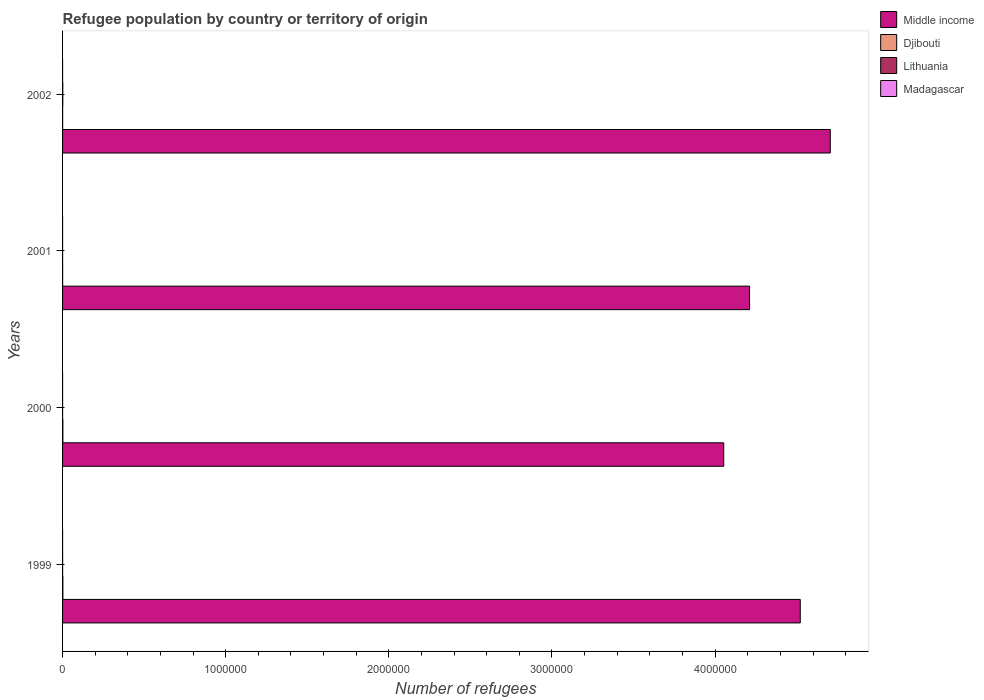How many groups of bars are there?
Ensure brevity in your answer.  4. Are the number of bars on each tick of the Y-axis equal?
Your answer should be very brief. Yes. What is the label of the 4th group of bars from the top?
Provide a short and direct response. 1999. In how many cases, is the number of bars for a given year not equal to the number of legend labels?
Provide a short and direct response. 0. What is the number of refugees in Lithuania in 1999?
Give a very brief answer. 258. Across all years, what is the maximum number of refugees in Djibouti?
Offer a very short reply. 1910. Across all years, what is the minimum number of refugees in Madagascar?
Your answer should be very brief. 40. In which year was the number of refugees in Madagascar minimum?
Your answer should be very brief. 2001. What is the difference between the number of refugees in Djibouti in 1999 and that in 2000?
Provide a succinct answer. -31. What is the difference between the number of refugees in Djibouti in 2001 and the number of refugees in Lithuania in 1999?
Ensure brevity in your answer.  194. What is the average number of refugees in Madagascar per year?
Your answer should be compact. 50.25. In the year 2001, what is the difference between the number of refugees in Middle income and number of refugees in Madagascar?
Provide a succinct answer. 4.21e+06. What is the ratio of the number of refugees in Djibouti in 2000 to that in 2002?
Your response must be concise. 4.06. Is the number of refugees in Madagascar in 2000 less than that in 2002?
Your answer should be very brief. No. Is the difference between the number of refugees in Middle income in 2000 and 2002 greater than the difference between the number of refugees in Madagascar in 2000 and 2002?
Your answer should be very brief. No. What is the difference between the highest and the lowest number of refugees in Djibouti?
Offer a terse response. 1458. Is the sum of the number of refugees in Lithuania in 2000 and 2001 greater than the maximum number of refugees in Madagascar across all years?
Provide a short and direct response. Yes. Is it the case that in every year, the sum of the number of refugees in Middle income and number of refugees in Madagascar is greater than the sum of number of refugees in Lithuania and number of refugees in Djibouti?
Provide a short and direct response. Yes. What does the 3rd bar from the top in 2001 represents?
Ensure brevity in your answer.  Djibouti. What does the 2nd bar from the bottom in 2001 represents?
Ensure brevity in your answer.  Djibouti. How many bars are there?
Offer a terse response. 16. How many years are there in the graph?
Your answer should be compact. 4. What is the difference between two consecutive major ticks on the X-axis?
Provide a short and direct response. 1.00e+06. Are the values on the major ticks of X-axis written in scientific E-notation?
Make the answer very short. No. Does the graph contain any zero values?
Your answer should be compact. No. Where does the legend appear in the graph?
Keep it short and to the point. Top right. What is the title of the graph?
Provide a short and direct response. Refugee population by country or territory of origin. Does "East Asia (developing only)" appear as one of the legend labels in the graph?
Your answer should be compact. No. What is the label or title of the X-axis?
Make the answer very short. Number of refugees. What is the label or title of the Y-axis?
Ensure brevity in your answer.  Years. What is the Number of refugees of Middle income in 1999?
Your answer should be very brief. 4.52e+06. What is the Number of refugees of Djibouti in 1999?
Keep it short and to the point. 1879. What is the Number of refugees of Lithuania in 1999?
Offer a very short reply. 258. What is the Number of refugees of Madagascar in 1999?
Offer a terse response. 54. What is the Number of refugees of Middle income in 2000?
Offer a terse response. 4.05e+06. What is the Number of refugees in Djibouti in 2000?
Offer a very short reply. 1910. What is the Number of refugees in Lithuania in 2000?
Give a very brief answer. 163. What is the Number of refugees in Madagascar in 2000?
Offer a very short reply. 54. What is the Number of refugees in Middle income in 2001?
Keep it short and to the point. 4.21e+06. What is the Number of refugees of Djibouti in 2001?
Offer a very short reply. 452. What is the Number of refugees of Lithuania in 2001?
Provide a short and direct response. 216. What is the Number of refugees in Madagascar in 2001?
Make the answer very short. 40. What is the Number of refugees in Middle income in 2002?
Make the answer very short. 4.71e+06. What is the Number of refugees of Djibouti in 2002?
Ensure brevity in your answer.  471. What is the Number of refugees of Lithuania in 2002?
Offer a terse response. 1371. Across all years, what is the maximum Number of refugees of Middle income?
Your response must be concise. 4.71e+06. Across all years, what is the maximum Number of refugees in Djibouti?
Make the answer very short. 1910. Across all years, what is the maximum Number of refugees of Lithuania?
Provide a succinct answer. 1371. Across all years, what is the minimum Number of refugees in Middle income?
Provide a succinct answer. 4.05e+06. Across all years, what is the minimum Number of refugees of Djibouti?
Provide a succinct answer. 452. Across all years, what is the minimum Number of refugees in Lithuania?
Provide a short and direct response. 163. Across all years, what is the minimum Number of refugees in Madagascar?
Make the answer very short. 40. What is the total Number of refugees in Middle income in the graph?
Keep it short and to the point. 1.75e+07. What is the total Number of refugees of Djibouti in the graph?
Give a very brief answer. 4712. What is the total Number of refugees of Lithuania in the graph?
Offer a very short reply. 2008. What is the total Number of refugees of Madagascar in the graph?
Give a very brief answer. 201. What is the difference between the Number of refugees of Middle income in 1999 and that in 2000?
Offer a terse response. 4.69e+05. What is the difference between the Number of refugees in Djibouti in 1999 and that in 2000?
Provide a succinct answer. -31. What is the difference between the Number of refugees of Middle income in 1999 and that in 2001?
Ensure brevity in your answer.  3.11e+05. What is the difference between the Number of refugees in Djibouti in 1999 and that in 2001?
Ensure brevity in your answer.  1427. What is the difference between the Number of refugees in Lithuania in 1999 and that in 2001?
Make the answer very short. 42. What is the difference between the Number of refugees in Madagascar in 1999 and that in 2001?
Provide a short and direct response. 14. What is the difference between the Number of refugees in Middle income in 1999 and that in 2002?
Offer a terse response. -1.84e+05. What is the difference between the Number of refugees of Djibouti in 1999 and that in 2002?
Keep it short and to the point. 1408. What is the difference between the Number of refugees of Lithuania in 1999 and that in 2002?
Offer a very short reply. -1113. What is the difference between the Number of refugees in Middle income in 2000 and that in 2001?
Keep it short and to the point. -1.58e+05. What is the difference between the Number of refugees of Djibouti in 2000 and that in 2001?
Your response must be concise. 1458. What is the difference between the Number of refugees of Lithuania in 2000 and that in 2001?
Your answer should be very brief. -53. What is the difference between the Number of refugees in Middle income in 2000 and that in 2002?
Make the answer very short. -6.53e+05. What is the difference between the Number of refugees in Djibouti in 2000 and that in 2002?
Your answer should be compact. 1439. What is the difference between the Number of refugees in Lithuania in 2000 and that in 2002?
Offer a terse response. -1208. What is the difference between the Number of refugees of Madagascar in 2000 and that in 2002?
Your answer should be compact. 1. What is the difference between the Number of refugees of Middle income in 2001 and that in 2002?
Offer a terse response. -4.95e+05. What is the difference between the Number of refugees in Lithuania in 2001 and that in 2002?
Keep it short and to the point. -1155. What is the difference between the Number of refugees of Madagascar in 2001 and that in 2002?
Provide a short and direct response. -13. What is the difference between the Number of refugees in Middle income in 1999 and the Number of refugees in Djibouti in 2000?
Provide a short and direct response. 4.52e+06. What is the difference between the Number of refugees in Middle income in 1999 and the Number of refugees in Lithuania in 2000?
Make the answer very short. 4.52e+06. What is the difference between the Number of refugees in Middle income in 1999 and the Number of refugees in Madagascar in 2000?
Give a very brief answer. 4.52e+06. What is the difference between the Number of refugees in Djibouti in 1999 and the Number of refugees in Lithuania in 2000?
Your answer should be compact. 1716. What is the difference between the Number of refugees in Djibouti in 1999 and the Number of refugees in Madagascar in 2000?
Give a very brief answer. 1825. What is the difference between the Number of refugees of Lithuania in 1999 and the Number of refugees of Madagascar in 2000?
Keep it short and to the point. 204. What is the difference between the Number of refugees in Middle income in 1999 and the Number of refugees in Djibouti in 2001?
Give a very brief answer. 4.52e+06. What is the difference between the Number of refugees in Middle income in 1999 and the Number of refugees in Lithuania in 2001?
Offer a terse response. 4.52e+06. What is the difference between the Number of refugees in Middle income in 1999 and the Number of refugees in Madagascar in 2001?
Your response must be concise. 4.52e+06. What is the difference between the Number of refugees in Djibouti in 1999 and the Number of refugees in Lithuania in 2001?
Provide a succinct answer. 1663. What is the difference between the Number of refugees of Djibouti in 1999 and the Number of refugees of Madagascar in 2001?
Provide a succinct answer. 1839. What is the difference between the Number of refugees in Lithuania in 1999 and the Number of refugees in Madagascar in 2001?
Your answer should be very brief. 218. What is the difference between the Number of refugees of Middle income in 1999 and the Number of refugees of Djibouti in 2002?
Your answer should be very brief. 4.52e+06. What is the difference between the Number of refugees in Middle income in 1999 and the Number of refugees in Lithuania in 2002?
Your response must be concise. 4.52e+06. What is the difference between the Number of refugees of Middle income in 1999 and the Number of refugees of Madagascar in 2002?
Your answer should be very brief. 4.52e+06. What is the difference between the Number of refugees of Djibouti in 1999 and the Number of refugees of Lithuania in 2002?
Your answer should be compact. 508. What is the difference between the Number of refugees in Djibouti in 1999 and the Number of refugees in Madagascar in 2002?
Offer a very short reply. 1826. What is the difference between the Number of refugees in Lithuania in 1999 and the Number of refugees in Madagascar in 2002?
Make the answer very short. 205. What is the difference between the Number of refugees in Middle income in 2000 and the Number of refugees in Djibouti in 2001?
Ensure brevity in your answer.  4.05e+06. What is the difference between the Number of refugees in Middle income in 2000 and the Number of refugees in Lithuania in 2001?
Offer a terse response. 4.05e+06. What is the difference between the Number of refugees of Middle income in 2000 and the Number of refugees of Madagascar in 2001?
Offer a terse response. 4.05e+06. What is the difference between the Number of refugees of Djibouti in 2000 and the Number of refugees of Lithuania in 2001?
Make the answer very short. 1694. What is the difference between the Number of refugees of Djibouti in 2000 and the Number of refugees of Madagascar in 2001?
Ensure brevity in your answer.  1870. What is the difference between the Number of refugees of Lithuania in 2000 and the Number of refugees of Madagascar in 2001?
Make the answer very short. 123. What is the difference between the Number of refugees in Middle income in 2000 and the Number of refugees in Djibouti in 2002?
Make the answer very short. 4.05e+06. What is the difference between the Number of refugees of Middle income in 2000 and the Number of refugees of Lithuania in 2002?
Your answer should be compact. 4.05e+06. What is the difference between the Number of refugees of Middle income in 2000 and the Number of refugees of Madagascar in 2002?
Provide a short and direct response. 4.05e+06. What is the difference between the Number of refugees of Djibouti in 2000 and the Number of refugees of Lithuania in 2002?
Your answer should be very brief. 539. What is the difference between the Number of refugees of Djibouti in 2000 and the Number of refugees of Madagascar in 2002?
Provide a short and direct response. 1857. What is the difference between the Number of refugees of Lithuania in 2000 and the Number of refugees of Madagascar in 2002?
Ensure brevity in your answer.  110. What is the difference between the Number of refugees in Middle income in 2001 and the Number of refugees in Djibouti in 2002?
Keep it short and to the point. 4.21e+06. What is the difference between the Number of refugees of Middle income in 2001 and the Number of refugees of Lithuania in 2002?
Give a very brief answer. 4.21e+06. What is the difference between the Number of refugees of Middle income in 2001 and the Number of refugees of Madagascar in 2002?
Ensure brevity in your answer.  4.21e+06. What is the difference between the Number of refugees of Djibouti in 2001 and the Number of refugees of Lithuania in 2002?
Ensure brevity in your answer.  -919. What is the difference between the Number of refugees in Djibouti in 2001 and the Number of refugees in Madagascar in 2002?
Offer a terse response. 399. What is the difference between the Number of refugees of Lithuania in 2001 and the Number of refugees of Madagascar in 2002?
Make the answer very short. 163. What is the average Number of refugees of Middle income per year?
Provide a short and direct response. 4.37e+06. What is the average Number of refugees in Djibouti per year?
Your answer should be very brief. 1178. What is the average Number of refugees of Lithuania per year?
Your response must be concise. 502. What is the average Number of refugees in Madagascar per year?
Your response must be concise. 50.25. In the year 1999, what is the difference between the Number of refugees in Middle income and Number of refugees in Djibouti?
Offer a terse response. 4.52e+06. In the year 1999, what is the difference between the Number of refugees of Middle income and Number of refugees of Lithuania?
Your answer should be very brief. 4.52e+06. In the year 1999, what is the difference between the Number of refugees of Middle income and Number of refugees of Madagascar?
Make the answer very short. 4.52e+06. In the year 1999, what is the difference between the Number of refugees of Djibouti and Number of refugees of Lithuania?
Offer a very short reply. 1621. In the year 1999, what is the difference between the Number of refugees of Djibouti and Number of refugees of Madagascar?
Keep it short and to the point. 1825. In the year 1999, what is the difference between the Number of refugees in Lithuania and Number of refugees in Madagascar?
Ensure brevity in your answer.  204. In the year 2000, what is the difference between the Number of refugees in Middle income and Number of refugees in Djibouti?
Your answer should be very brief. 4.05e+06. In the year 2000, what is the difference between the Number of refugees in Middle income and Number of refugees in Lithuania?
Your response must be concise. 4.05e+06. In the year 2000, what is the difference between the Number of refugees in Middle income and Number of refugees in Madagascar?
Keep it short and to the point. 4.05e+06. In the year 2000, what is the difference between the Number of refugees of Djibouti and Number of refugees of Lithuania?
Offer a terse response. 1747. In the year 2000, what is the difference between the Number of refugees in Djibouti and Number of refugees in Madagascar?
Offer a terse response. 1856. In the year 2000, what is the difference between the Number of refugees in Lithuania and Number of refugees in Madagascar?
Your answer should be very brief. 109. In the year 2001, what is the difference between the Number of refugees of Middle income and Number of refugees of Djibouti?
Make the answer very short. 4.21e+06. In the year 2001, what is the difference between the Number of refugees of Middle income and Number of refugees of Lithuania?
Ensure brevity in your answer.  4.21e+06. In the year 2001, what is the difference between the Number of refugees in Middle income and Number of refugees in Madagascar?
Give a very brief answer. 4.21e+06. In the year 2001, what is the difference between the Number of refugees of Djibouti and Number of refugees of Lithuania?
Your answer should be very brief. 236. In the year 2001, what is the difference between the Number of refugees in Djibouti and Number of refugees in Madagascar?
Ensure brevity in your answer.  412. In the year 2001, what is the difference between the Number of refugees of Lithuania and Number of refugees of Madagascar?
Provide a succinct answer. 176. In the year 2002, what is the difference between the Number of refugees in Middle income and Number of refugees in Djibouti?
Your response must be concise. 4.71e+06. In the year 2002, what is the difference between the Number of refugees of Middle income and Number of refugees of Lithuania?
Your answer should be very brief. 4.70e+06. In the year 2002, what is the difference between the Number of refugees of Middle income and Number of refugees of Madagascar?
Your answer should be compact. 4.71e+06. In the year 2002, what is the difference between the Number of refugees in Djibouti and Number of refugees in Lithuania?
Ensure brevity in your answer.  -900. In the year 2002, what is the difference between the Number of refugees in Djibouti and Number of refugees in Madagascar?
Provide a succinct answer. 418. In the year 2002, what is the difference between the Number of refugees in Lithuania and Number of refugees in Madagascar?
Give a very brief answer. 1318. What is the ratio of the Number of refugees in Middle income in 1999 to that in 2000?
Provide a short and direct response. 1.12. What is the ratio of the Number of refugees of Djibouti in 1999 to that in 2000?
Ensure brevity in your answer.  0.98. What is the ratio of the Number of refugees in Lithuania in 1999 to that in 2000?
Keep it short and to the point. 1.58. What is the ratio of the Number of refugees of Madagascar in 1999 to that in 2000?
Your answer should be very brief. 1. What is the ratio of the Number of refugees of Middle income in 1999 to that in 2001?
Your answer should be very brief. 1.07. What is the ratio of the Number of refugees in Djibouti in 1999 to that in 2001?
Your response must be concise. 4.16. What is the ratio of the Number of refugees of Lithuania in 1999 to that in 2001?
Make the answer very short. 1.19. What is the ratio of the Number of refugees in Madagascar in 1999 to that in 2001?
Keep it short and to the point. 1.35. What is the ratio of the Number of refugees of Middle income in 1999 to that in 2002?
Your answer should be compact. 0.96. What is the ratio of the Number of refugees in Djibouti in 1999 to that in 2002?
Offer a terse response. 3.99. What is the ratio of the Number of refugees of Lithuania in 1999 to that in 2002?
Ensure brevity in your answer.  0.19. What is the ratio of the Number of refugees of Madagascar in 1999 to that in 2002?
Offer a terse response. 1.02. What is the ratio of the Number of refugees in Middle income in 2000 to that in 2001?
Your answer should be compact. 0.96. What is the ratio of the Number of refugees in Djibouti in 2000 to that in 2001?
Offer a terse response. 4.23. What is the ratio of the Number of refugees of Lithuania in 2000 to that in 2001?
Provide a short and direct response. 0.75. What is the ratio of the Number of refugees of Madagascar in 2000 to that in 2001?
Give a very brief answer. 1.35. What is the ratio of the Number of refugees in Middle income in 2000 to that in 2002?
Make the answer very short. 0.86. What is the ratio of the Number of refugees in Djibouti in 2000 to that in 2002?
Make the answer very short. 4.06. What is the ratio of the Number of refugees in Lithuania in 2000 to that in 2002?
Offer a very short reply. 0.12. What is the ratio of the Number of refugees in Madagascar in 2000 to that in 2002?
Give a very brief answer. 1.02. What is the ratio of the Number of refugees in Middle income in 2001 to that in 2002?
Keep it short and to the point. 0.89. What is the ratio of the Number of refugees in Djibouti in 2001 to that in 2002?
Your answer should be very brief. 0.96. What is the ratio of the Number of refugees in Lithuania in 2001 to that in 2002?
Provide a short and direct response. 0.16. What is the ratio of the Number of refugees in Madagascar in 2001 to that in 2002?
Offer a very short reply. 0.75. What is the difference between the highest and the second highest Number of refugees of Middle income?
Offer a very short reply. 1.84e+05. What is the difference between the highest and the second highest Number of refugees of Lithuania?
Give a very brief answer. 1113. What is the difference between the highest and the lowest Number of refugees of Middle income?
Provide a short and direct response. 6.53e+05. What is the difference between the highest and the lowest Number of refugees in Djibouti?
Offer a terse response. 1458. What is the difference between the highest and the lowest Number of refugees of Lithuania?
Provide a succinct answer. 1208. What is the difference between the highest and the lowest Number of refugees in Madagascar?
Give a very brief answer. 14. 